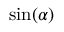Convert formula to latex. <formula><loc_0><loc_0><loc_500><loc_500>\sin ( \alpha )</formula> 